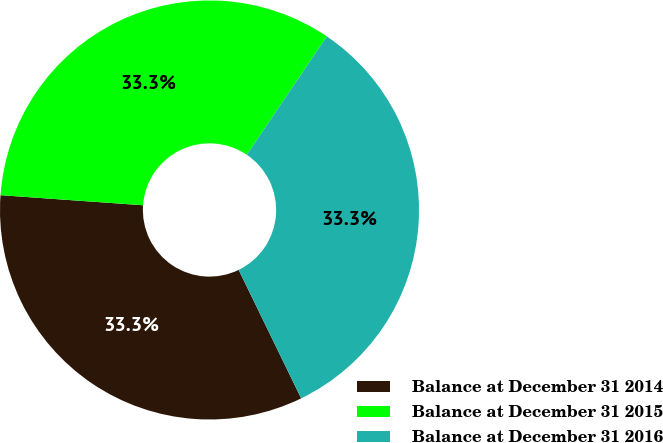Convert chart to OTSL. <chart><loc_0><loc_0><loc_500><loc_500><pie_chart><fcel>Balance at December 31 2014<fcel>Balance at December 31 2015<fcel>Balance at December 31 2016<nl><fcel>33.33%<fcel>33.33%<fcel>33.33%<nl></chart> 